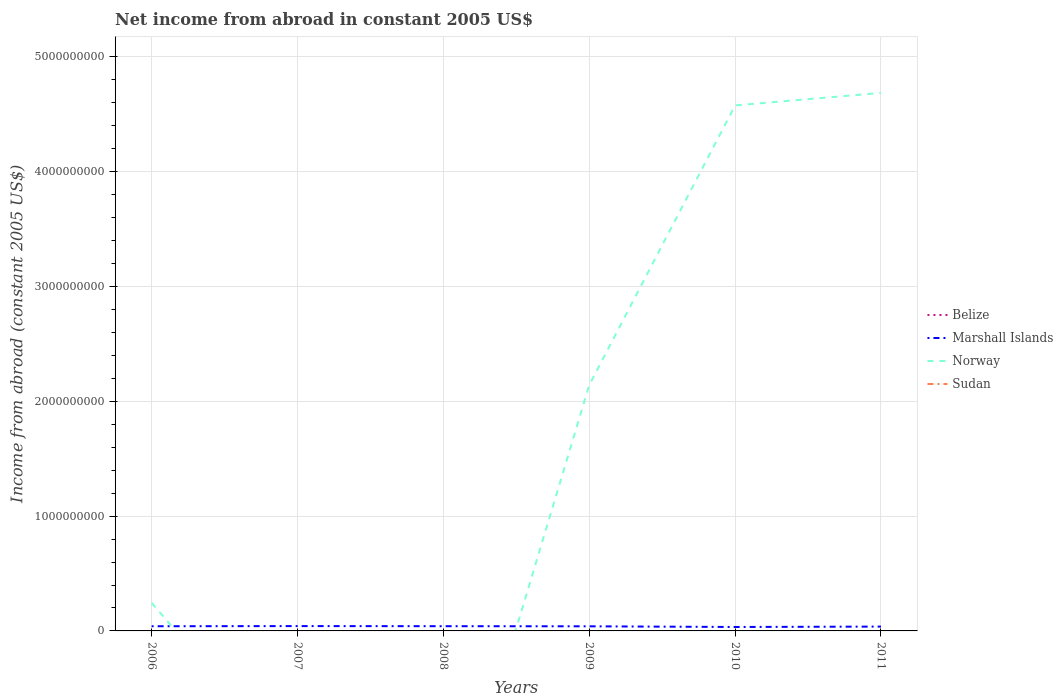Does the line corresponding to Norway intersect with the line corresponding to Sudan?
Keep it short and to the point. No. What is the total net income from abroad in Marshall Islands in the graph?
Your response must be concise. 5.84e+06. What is the difference between the highest and the second highest net income from abroad in Marshall Islands?
Provide a succinct answer. 7.82e+06. What is the difference between the highest and the lowest net income from abroad in Sudan?
Your answer should be compact. 0. What is the difference between two consecutive major ticks on the Y-axis?
Offer a very short reply. 1.00e+09. Where does the legend appear in the graph?
Your answer should be compact. Center right. How many legend labels are there?
Your response must be concise. 4. What is the title of the graph?
Give a very brief answer. Net income from abroad in constant 2005 US$. What is the label or title of the X-axis?
Make the answer very short. Years. What is the label or title of the Y-axis?
Your response must be concise. Income from abroad (constant 2005 US$). What is the Income from abroad (constant 2005 US$) in Belize in 2006?
Provide a succinct answer. 0. What is the Income from abroad (constant 2005 US$) in Marshall Islands in 2006?
Make the answer very short. 4.07e+07. What is the Income from abroad (constant 2005 US$) of Norway in 2006?
Ensure brevity in your answer.  2.45e+08. What is the Income from abroad (constant 2005 US$) in Belize in 2007?
Ensure brevity in your answer.  0. What is the Income from abroad (constant 2005 US$) of Marshall Islands in 2007?
Ensure brevity in your answer.  4.21e+07. What is the Income from abroad (constant 2005 US$) in Sudan in 2007?
Your answer should be very brief. 0. What is the Income from abroad (constant 2005 US$) in Marshall Islands in 2008?
Provide a short and direct response. 4.12e+07. What is the Income from abroad (constant 2005 US$) in Norway in 2008?
Your answer should be compact. 0. What is the Income from abroad (constant 2005 US$) in Marshall Islands in 2009?
Provide a succinct answer. 4.02e+07. What is the Income from abroad (constant 2005 US$) in Norway in 2009?
Give a very brief answer. 2.14e+09. What is the Income from abroad (constant 2005 US$) of Marshall Islands in 2010?
Give a very brief answer. 3.43e+07. What is the Income from abroad (constant 2005 US$) in Norway in 2010?
Provide a short and direct response. 4.58e+09. What is the Income from abroad (constant 2005 US$) in Belize in 2011?
Provide a short and direct response. 0. What is the Income from abroad (constant 2005 US$) in Marshall Islands in 2011?
Ensure brevity in your answer.  3.78e+07. What is the Income from abroad (constant 2005 US$) of Norway in 2011?
Ensure brevity in your answer.  4.69e+09. What is the Income from abroad (constant 2005 US$) in Sudan in 2011?
Your response must be concise. 0. Across all years, what is the maximum Income from abroad (constant 2005 US$) of Marshall Islands?
Provide a short and direct response. 4.21e+07. Across all years, what is the maximum Income from abroad (constant 2005 US$) of Norway?
Give a very brief answer. 4.69e+09. Across all years, what is the minimum Income from abroad (constant 2005 US$) in Marshall Islands?
Your response must be concise. 3.43e+07. What is the total Income from abroad (constant 2005 US$) of Marshall Islands in the graph?
Give a very brief answer. 2.36e+08. What is the total Income from abroad (constant 2005 US$) in Norway in the graph?
Give a very brief answer. 1.17e+1. What is the difference between the Income from abroad (constant 2005 US$) of Marshall Islands in 2006 and that in 2007?
Give a very brief answer. -1.44e+06. What is the difference between the Income from abroad (constant 2005 US$) of Marshall Islands in 2006 and that in 2008?
Give a very brief answer. -4.69e+05. What is the difference between the Income from abroad (constant 2005 US$) in Marshall Islands in 2006 and that in 2009?
Your answer should be compact. 5.33e+05. What is the difference between the Income from abroad (constant 2005 US$) of Norway in 2006 and that in 2009?
Offer a terse response. -1.90e+09. What is the difference between the Income from abroad (constant 2005 US$) of Marshall Islands in 2006 and that in 2010?
Your response must be concise. 6.38e+06. What is the difference between the Income from abroad (constant 2005 US$) of Norway in 2006 and that in 2010?
Your answer should be very brief. -4.33e+09. What is the difference between the Income from abroad (constant 2005 US$) in Marshall Islands in 2006 and that in 2011?
Ensure brevity in your answer.  2.90e+06. What is the difference between the Income from abroad (constant 2005 US$) of Norway in 2006 and that in 2011?
Make the answer very short. -4.44e+09. What is the difference between the Income from abroad (constant 2005 US$) in Marshall Islands in 2007 and that in 2008?
Ensure brevity in your answer.  9.72e+05. What is the difference between the Income from abroad (constant 2005 US$) of Marshall Islands in 2007 and that in 2009?
Your response must be concise. 1.97e+06. What is the difference between the Income from abroad (constant 2005 US$) in Marshall Islands in 2007 and that in 2010?
Ensure brevity in your answer.  7.82e+06. What is the difference between the Income from abroad (constant 2005 US$) in Marshall Islands in 2007 and that in 2011?
Your answer should be very brief. 4.34e+06. What is the difference between the Income from abroad (constant 2005 US$) of Marshall Islands in 2008 and that in 2009?
Your answer should be very brief. 1.00e+06. What is the difference between the Income from abroad (constant 2005 US$) of Marshall Islands in 2008 and that in 2010?
Provide a short and direct response. 6.85e+06. What is the difference between the Income from abroad (constant 2005 US$) of Marshall Islands in 2008 and that in 2011?
Your answer should be very brief. 3.37e+06. What is the difference between the Income from abroad (constant 2005 US$) in Marshall Islands in 2009 and that in 2010?
Provide a short and direct response. 5.84e+06. What is the difference between the Income from abroad (constant 2005 US$) of Norway in 2009 and that in 2010?
Offer a very short reply. -2.44e+09. What is the difference between the Income from abroad (constant 2005 US$) of Marshall Islands in 2009 and that in 2011?
Your response must be concise. 2.37e+06. What is the difference between the Income from abroad (constant 2005 US$) in Norway in 2009 and that in 2011?
Provide a short and direct response. -2.54e+09. What is the difference between the Income from abroad (constant 2005 US$) of Marshall Islands in 2010 and that in 2011?
Provide a short and direct response. -3.48e+06. What is the difference between the Income from abroad (constant 2005 US$) of Norway in 2010 and that in 2011?
Keep it short and to the point. -1.09e+08. What is the difference between the Income from abroad (constant 2005 US$) in Marshall Islands in 2006 and the Income from abroad (constant 2005 US$) in Norway in 2009?
Provide a succinct answer. -2.10e+09. What is the difference between the Income from abroad (constant 2005 US$) of Marshall Islands in 2006 and the Income from abroad (constant 2005 US$) of Norway in 2010?
Ensure brevity in your answer.  -4.54e+09. What is the difference between the Income from abroad (constant 2005 US$) of Marshall Islands in 2006 and the Income from abroad (constant 2005 US$) of Norway in 2011?
Offer a terse response. -4.65e+09. What is the difference between the Income from abroad (constant 2005 US$) of Marshall Islands in 2007 and the Income from abroad (constant 2005 US$) of Norway in 2009?
Provide a short and direct response. -2.10e+09. What is the difference between the Income from abroad (constant 2005 US$) in Marshall Islands in 2007 and the Income from abroad (constant 2005 US$) in Norway in 2010?
Offer a terse response. -4.54e+09. What is the difference between the Income from abroad (constant 2005 US$) of Marshall Islands in 2007 and the Income from abroad (constant 2005 US$) of Norway in 2011?
Your response must be concise. -4.64e+09. What is the difference between the Income from abroad (constant 2005 US$) in Marshall Islands in 2008 and the Income from abroad (constant 2005 US$) in Norway in 2009?
Make the answer very short. -2.10e+09. What is the difference between the Income from abroad (constant 2005 US$) in Marshall Islands in 2008 and the Income from abroad (constant 2005 US$) in Norway in 2010?
Your answer should be compact. -4.54e+09. What is the difference between the Income from abroad (constant 2005 US$) in Marshall Islands in 2008 and the Income from abroad (constant 2005 US$) in Norway in 2011?
Give a very brief answer. -4.65e+09. What is the difference between the Income from abroad (constant 2005 US$) of Marshall Islands in 2009 and the Income from abroad (constant 2005 US$) of Norway in 2010?
Make the answer very short. -4.54e+09. What is the difference between the Income from abroad (constant 2005 US$) of Marshall Islands in 2009 and the Income from abroad (constant 2005 US$) of Norway in 2011?
Provide a short and direct response. -4.65e+09. What is the difference between the Income from abroad (constant 2005 US$) of Marshall Islands in 2010 and the Income from abroad (constant 2005 US$) of Norway in 2011?
Offer a very short reply. -4.65e+09. What is the average Income from abroad (constant 2005 US$) of Belize per year?
Provide a succinct answer. 0. What is the average Income from abroad (constant 2005 US$) of Marshall Islands per year?
Offer a very short reply. 3.94e+07. What is the average Income from abroad (constant 2005 US$) of Norway per year?
Offer a terse response. 1.94e+09. What is the average Income from abroad (constant 2005 US$) in Sudan per year?
Provide a succinct answer. 0. In the year 2006, what is the difference between the Income from abroad (constant 2005 US$) of Marshall Islands and Income from abroad (constant 2005 US$) of Norway?
Ensure brevity in your answer.  -2.04e+08. In the year 2009, what is the difference between the Income from abroad (constant 2005 US$) in Marshall Islands and Income from abroad (constant 2005 US$) in Norway?
Your answer should be very brief. -2.10e+09. In the year 2010, what is the difference between the Income from abroad (constant 2005 US$) in Marshall Islands and Income from abroad (constant 2005 US$) in Norway?
Offer a terse response. -4.54e+09. In the year 2011, what is the difference between the Income from abroad (constant 2005 US$) of Marshall Islands and Income from abroad (constant 2005 US$) of Norway?
Provide a succinct answer. -4.65e+09. What is the ratio of the Income from abroad (constant 2005 US$) of Marshall Islands in 2006 to that in 2007?
Make the answer very short. 0.97. What is the ratio of the Income from abroad (constant 2005 US$) in Marshall Islands in 2006 to that in 2009?
Offer a very short reply. 1.01. What is the ratio of the Income from abroad (constant 2005 US$) in Norway in 2006 to that in 2009?
Offer a terse response. 0.11. What is the ratio of the Income from abroad (constant 2005 US$) in Marshall Islands in 2006 to that in 2010?
Ensure brevity in your answer.  1.19. What is the ratio of the Income from abroad (constant 2005 US$) in Norway in 2006 to that in 2010?
Make the answer very short. 0.05. What is the ratio of the Income from abroad (constant 2005 US$) in Marshall Islands in 2006 to that in 2011?
Give a very brief answer. 1.08. What is the ratio of the Income from abroad (constant 2005 US$) in Norway in 2006 to that in 2011?
Provide a succinct answer. 0.05. What is the ratio of the Income from abroad (constant 2005 US$) of Marshall Islands in 2007 to that in 2008?
Offer a terse response. 1.02. What is the ratio of the Income from abroad (constant 2005 US$) of Marshall Islands in 2007 to that in 2009?
Give a very brief answer. 1.05. What is the ratio of the Income from abroad (constant 2005 US$) of Marshall Islands in 2007 to that in 2010?
Give a very brief answer. 1.23. What is the ratio of the Income from abroad (constant 2005 US$) in Marshall Islands in 2007 to that in 2011?
Keep it short and to the point. 1.11. What is the ratio of the Income from abroad (constant 2005 US$) of Marshall Islands in 2008 to that in 2009?
Your answer should be compact. 1.02. What is the ratio of the Income from abroad (constant 2005 US$) in Marshall Islands in 2008 to that in 2010?
Offer a very short reply. 1.2. What is the ratio of the Income from abroad (constant 2005 US$) of Marshall Islands in 2008 to that in 2011?
Make the answer very short. 1.09. What is the ratio of the Income from abroad (constant 2005 US$) in Marshall Islands in 2009 to that in 2010?
Keep it short and to the point. 1.17. What is the ratio of the Income from abroad (constant 2005 US$) in Norway in 2009 to that in 2010?
Your answer should be very brief. 0.47. What is the ratio of the Income from abroad (constant 2005 US$) in Marshall Islands in 2009 to that in 2011?
Provide a short and direct response. 1.06. What is the ratio of the Income from abroad (constant 2005 US$) of Norway in 2009 to that in 2011?
Provide a short and direct response. 0.46. What is the ratio of the Income from abroad (constant 2005 US$) in Marshall Islands in 2010 to that in 2011?
Your answer should be compact. 0.91. What is the ratio of the Income from abroad (constant 2005 US$) of Norway in 2010 to that in 2011?
Ensure brevity in your answer.  0.98. What is the difference between the highest and the second highest Income from abroad (constant 2005 US$) in Marshall Islands?
Provide a succinct answer. 9.72e+05. What is the difference between the highest and the second highest Income from abroad (constant 2005 US$) of Norway?
Provide a succinct answer. 1.09e+08. What is the difference between the highest and the lowest Income from abroad (constant 2005 US$) in Marshall Islands?
Offer a terse response. 7.82e+06. What is the difference between the highest and the lowest Income from abroad (constant 2005 US$) in Norway?
Ensure brevity in your answer.  4.69e+09. 